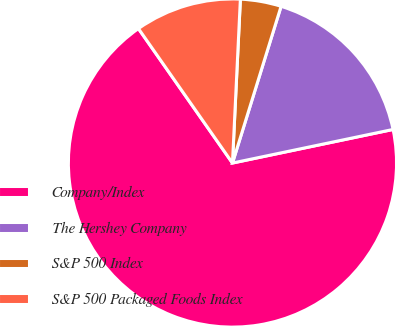Convert chart to OTSL. <chart><loc_0><loc_0><loc_500><loc_500><pie_chart><fcel>Company/Index<fcel>The Hershey Company<fcel>S&P 500 Index<fcel>S&P 500 Packaged Foods Index<nl><fcel>68.57%<fcel>16.93%<fcel>4.02%<fcel>10.48%<nl></chart> 